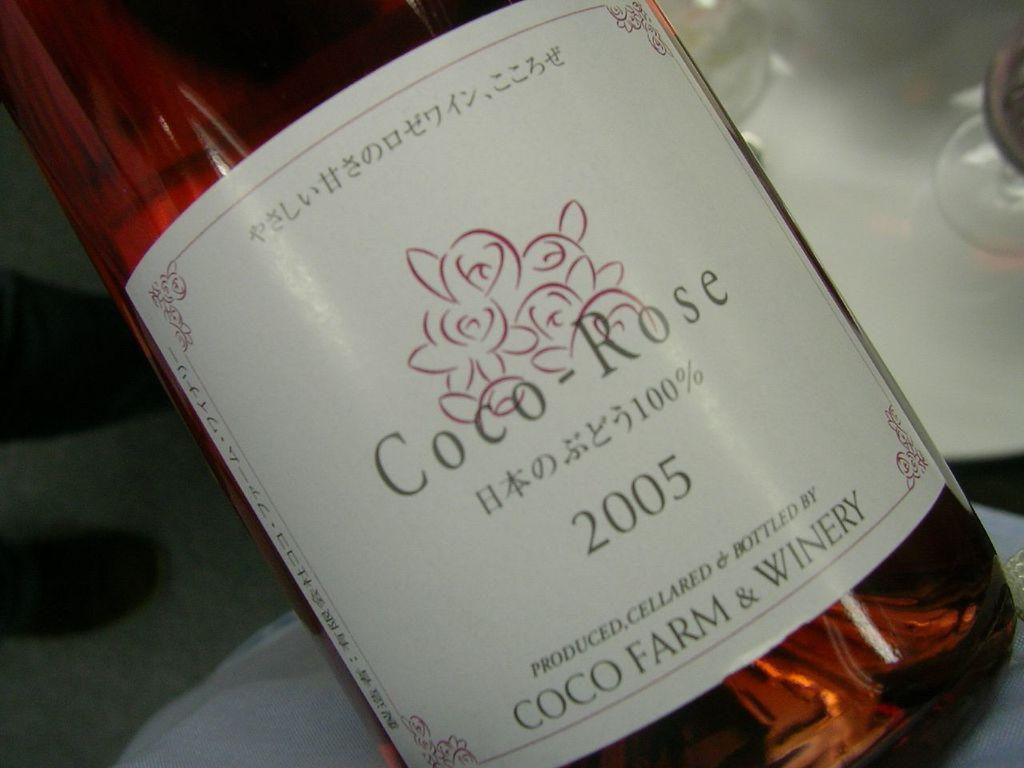<image>
Share a concise interpretation of the image provided. the word coco that is on a bottle 